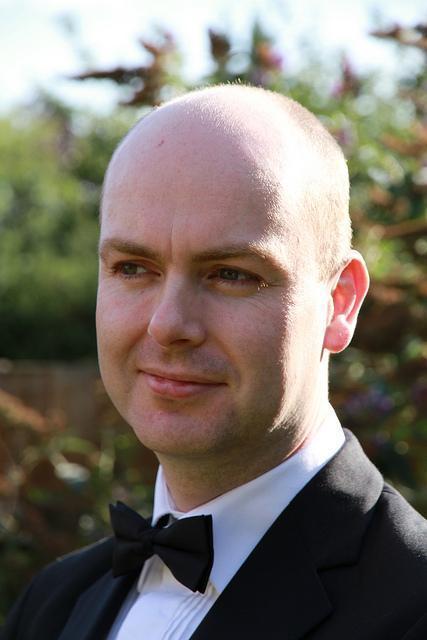How many faucets does the sink have?
Give a very brief answer. 0. 